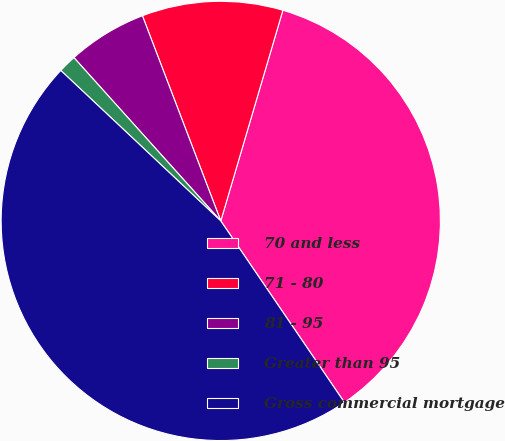Convert chart. <chart><loc_0><loc_0><loc_500><loc_500><pie_chart><fcel>70 and less<fcel>71 - 80<fcel>81 - 95<fcel>Greater than 95<fcel>Gross commercial mortgage<nl><fcel>35.92%<fcel>10.37%<fcel>5.85%<fcel>1.33%<fcel>46.53%<nl></chart> 